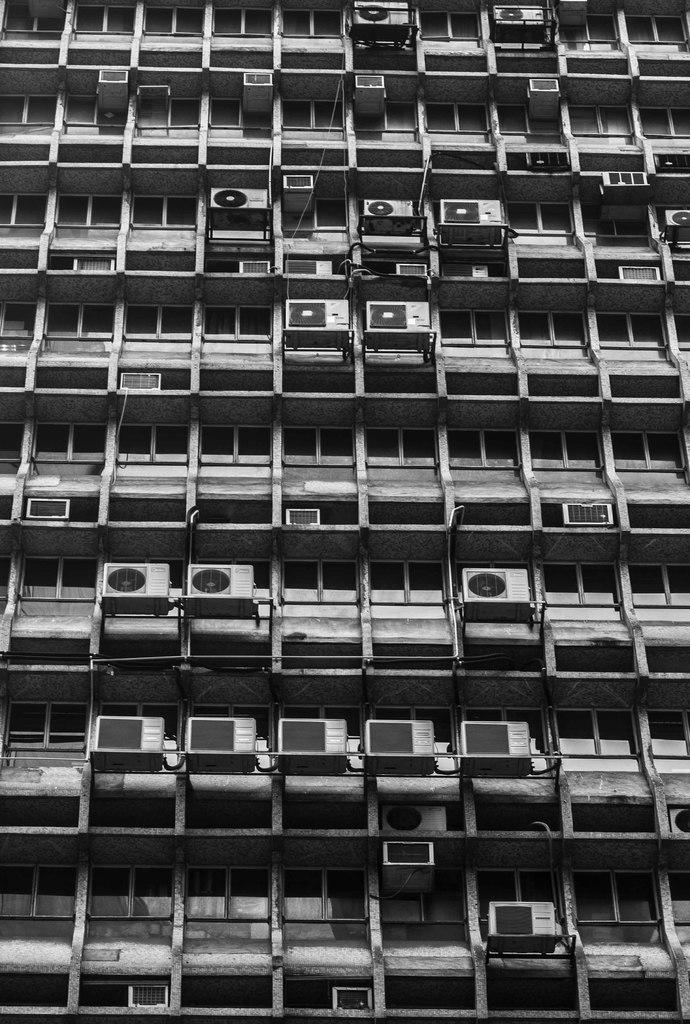What type of structure is present in the image? There is a building in the image. What feature of the building can be seen in the image? The building has ACs (air conditioners). How many quarters can be seen on the doll in the image? There is no doll present in the image, and therefore no quarters can be seen on it. 